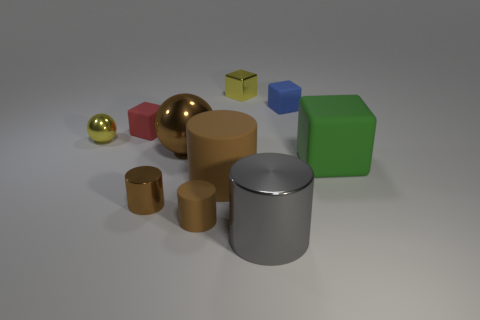How many metal things are either big gray cylinders or big yellow cylinders?
Your answer should be compact. 1. There is another small matte thing that is the same shape as the tiny blue object; what is its color?
Make the answer very short. Red. Are any purple metal cylinders visible?
Make the answer very short. No. Are the tiny yellow thing behind the red matte block and the small block to the right of the yellow cube made of the same material?
Your answer should be compact. No. What shape is the small shiny thing that is the same color as the small matte cylinder?
Offer a terse response. Cylinder. How many things are either cubes behind the large brown sphere or objects that are in front of the yellow shiny sphere?
Provide a short and direct response. 9. Does the big metallic thing that is behind the large green object have the same color as the large matte cylinder that is in front of the big cube?
Give a very brief answer. Yes. What is the shape of the tiny metal object that is both on the right side of the small yellow metallic ball and behind the green thing?
Provide a succinct answer. Cube. There is a shiny ball that is the same size as the green matte thing; what color is it?
Your answer should be very brief. Brown. Is there a metallic thing of the same color as the tiny metal cube?
Give a very brief answer. Yes. 